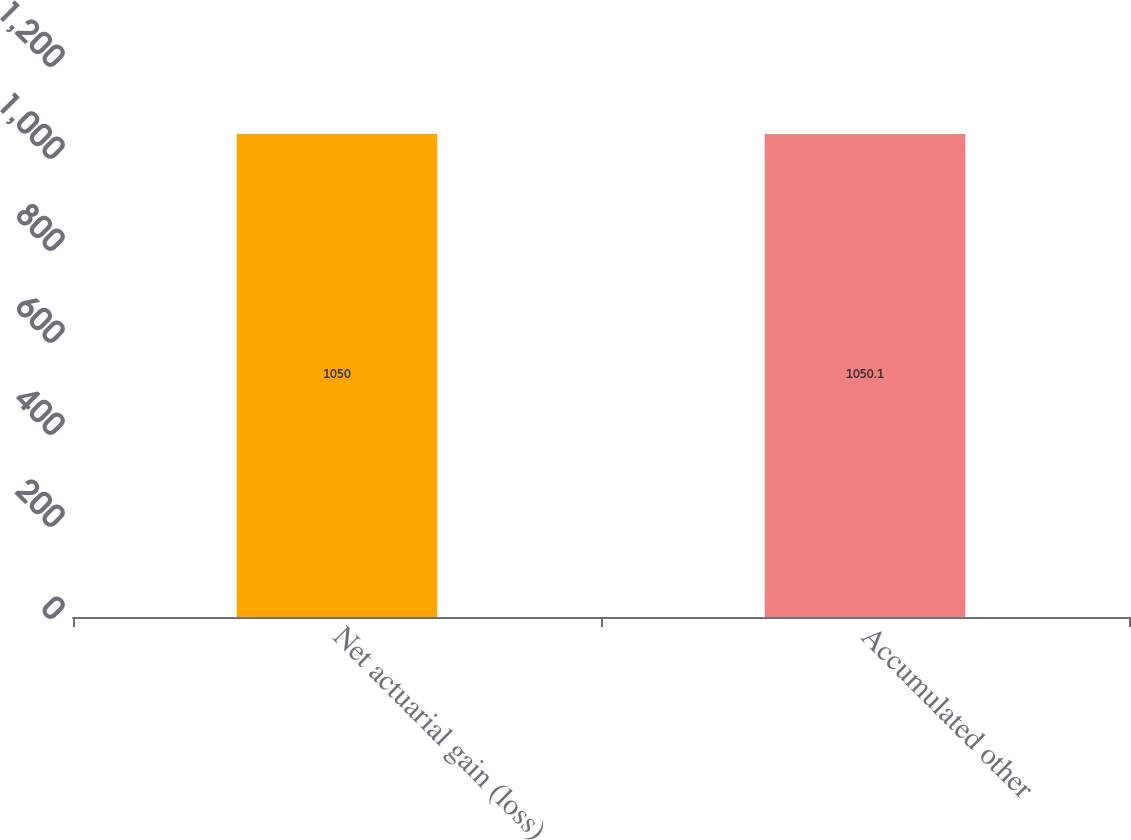<chart> <loc_0><loc_0><loc_500><loc_500><bar_chart><fcel>Net actuarial gain (loss)<fcel>Accumulated other<nl><fcel>1050<fcel>1050.1<nl></chart> 